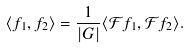<formula> <loc_0><loc_0><loc_500><loc_500>\langle f _ { 1 } , f _ { 2 } \rangle = \frac { 1 } { | G | } \langle \mathcal { F } f _ { 1 } , \mathcal { F } f _ { 2 } \rangle .</formula> 